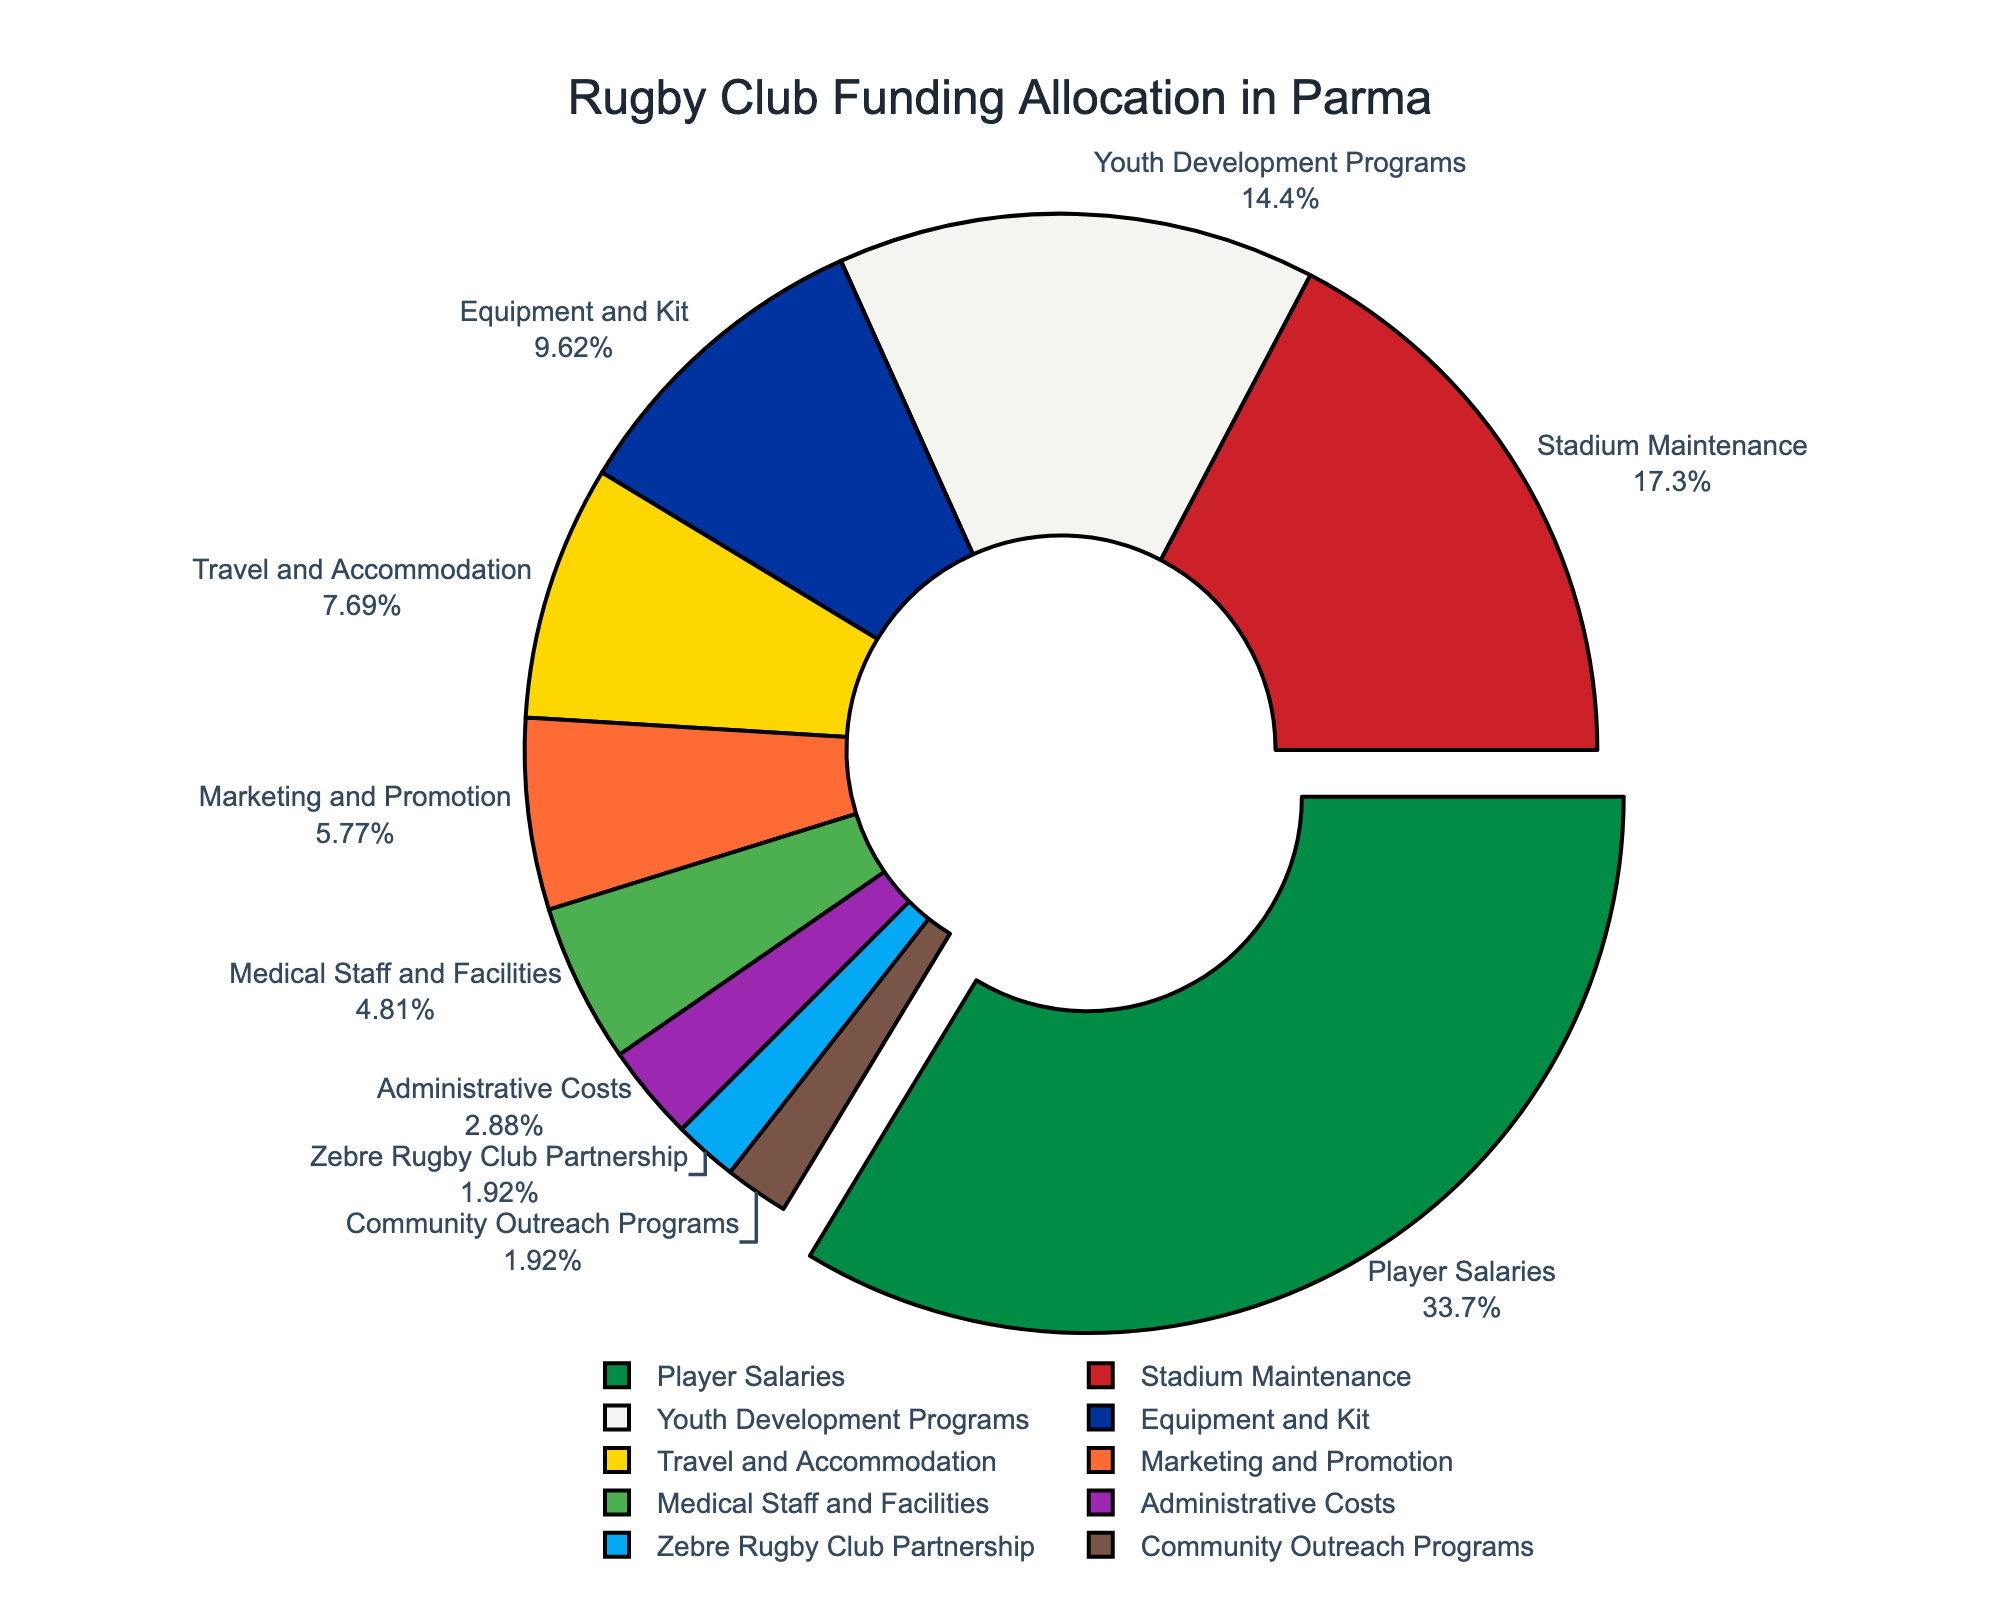What percentage of the funding is allocated to player salaries? The pie chart shows that player salaries take up the largest slice. The percentage marked for player salaries is 35%.
Answer: 35% What are the top three categories in terms of funding allocation? By examining the sizes and the percentages of the slices, the top three categories are Player Salaries (35%), Stadium Maintenance (18%), and Youth Development Programs (15%).
Answer: Player Salaries, Stadium Maintenance, Youth Development Programs How much more funding is allocated to equipment and kit compared to community outreach programs? The percentage for Equipment and Kit is 10%, and for Community Outreach Programs, it is 2%. The difference is 10% - 2% = 8% more allocated to Equipment and Kit.
Answer: 8% Which category receives the least amount of funding? From the pie chart, the slices for Zebre Rugby Club Partnership and Community Outreach Programs are the smallest at 2% each.
Answer: Zebre Rugby Club Partnership, Community Outreach Programs What is the combined percentage of funding for medical staff and facilities and administrative costs? Medical Staff and Facilities receive 5% and Administrative Costs receive 3%. The combined percentage is 5% + 3% = 8%.
Answer: 8% How does the funding for travel and accommodation compare with marketing and promotion? The slice for Travel and Accommodation represents 8%, while Marketing and Promotion represents 6%. Travel and Accommodation has a higher percentage compared to Marketing and Promotion by 2%.
Answer: 2% more If you sum the funding for stadium maintenance and youth development programs, what percentage do you get? Stadium Maintenance is 18% and Youth Development Programs is 15%. Their sum is 18% + 15% = 33%.
Answer: 33% Identify the category that has a funding allocation of 6%. The pie chart shows that Marketing and Promotion has a 6% allocation, marked distinctly on its respective slice.
Answer: Marketing and Promotion What is the percentage difference between the highest and the lowest funded categories? The highest percentage is for Player Salaries at 35%, and the lowest percentages are for Zebre Rugby Club Partnership and Community Outreach Programs at 2%. The difference is 35% - 2% = 33%.
Answer: 33% 